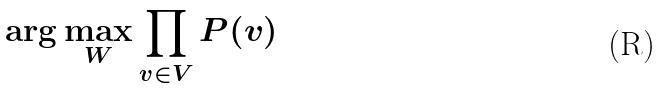<formula> <loc_0><loc_0><loc_500><loc_500>\arg \max _ { W } \prod _ { v \in V } P ( v )</formula> 